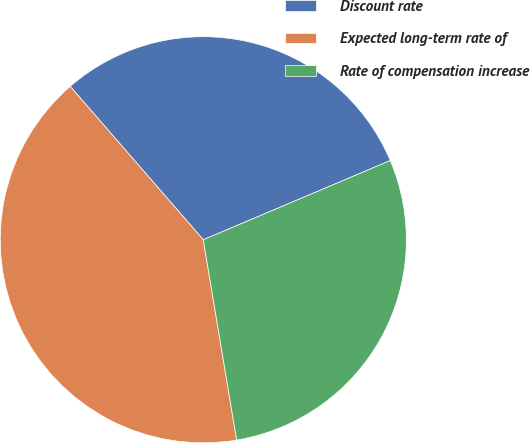<chart> <loc_0><loc_0><loc_500><loc_500><pie_chart><fcel>Discount rate<fcel>Expected long-term rate of<fcel>Rate of compensation increase<nl><fcel>30.0%<fcel>41.25%<fcel>28.75%<nl></chart> 